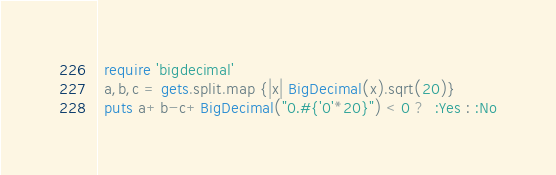<code> <loc_0><loc_0><loc_500><loc_500><_Ruby_> require 'bigdecimal'
 a,b,c = gets.split.map {|x| BigDecimal(x).sqrt(20)}
 puts a+b-c+BigDecimal("0.#{'0'*20}") < 0 ?  :Yes : :No</code> 